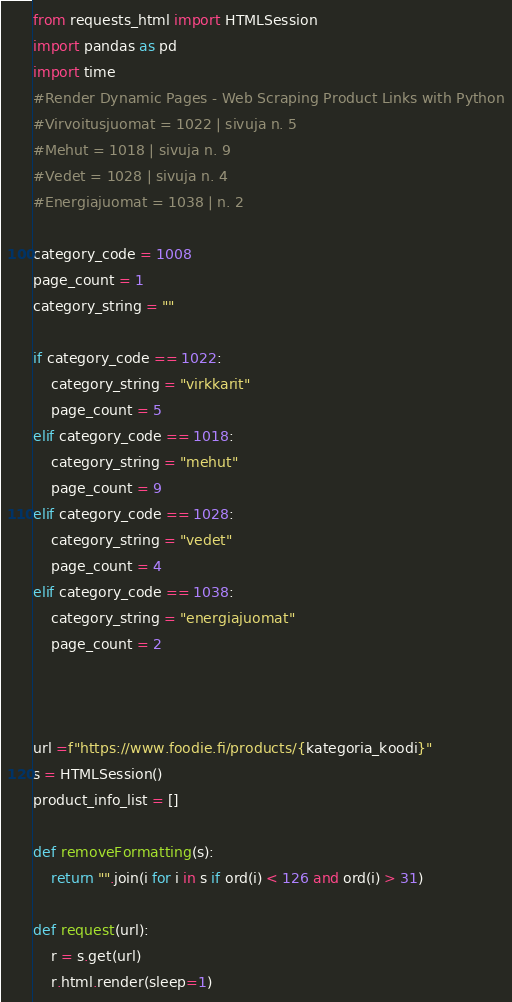<code> <loc_0><loc_0><loc_500><loc_500><_Python_>from requests_html import HTMLSession
import pandas as pd
import time
#Render Dynamic Pages - Web Scraping Product Links with Python
#Virvoitusjuomat = 1022 | sivuja n. 5
#Mehut = 1018 | sivuja n. 9
#Vedet = 1028 | sivuja n. 4
#Energiajuomat = 1038 | n. 2

category_code = 1008
page_count = 1
category_string = ""

if category_code == 1022:
    category_string = "virkkarit"
    page_count = 5
elif category_code == 1018:
    category_string = "mehut"
    page_count = 9
elif category_code == 1028:
    category_string = "vedet"
    page_count = 4
elif category_code == 1038:
    category_string = "energiajuomat"
    page_count = 2



url =f"https://www.foodie.fi/products/{kategoria_koodi}"
s = HTMLSession()
product_info_list = []

def removeFormatting(s):
    return "".join(i for i in s if ord(i) < 126 and ord(i) > 31)

def request(url):
    r = s.get(url)
    r.html.render(sleep=1)</code> 